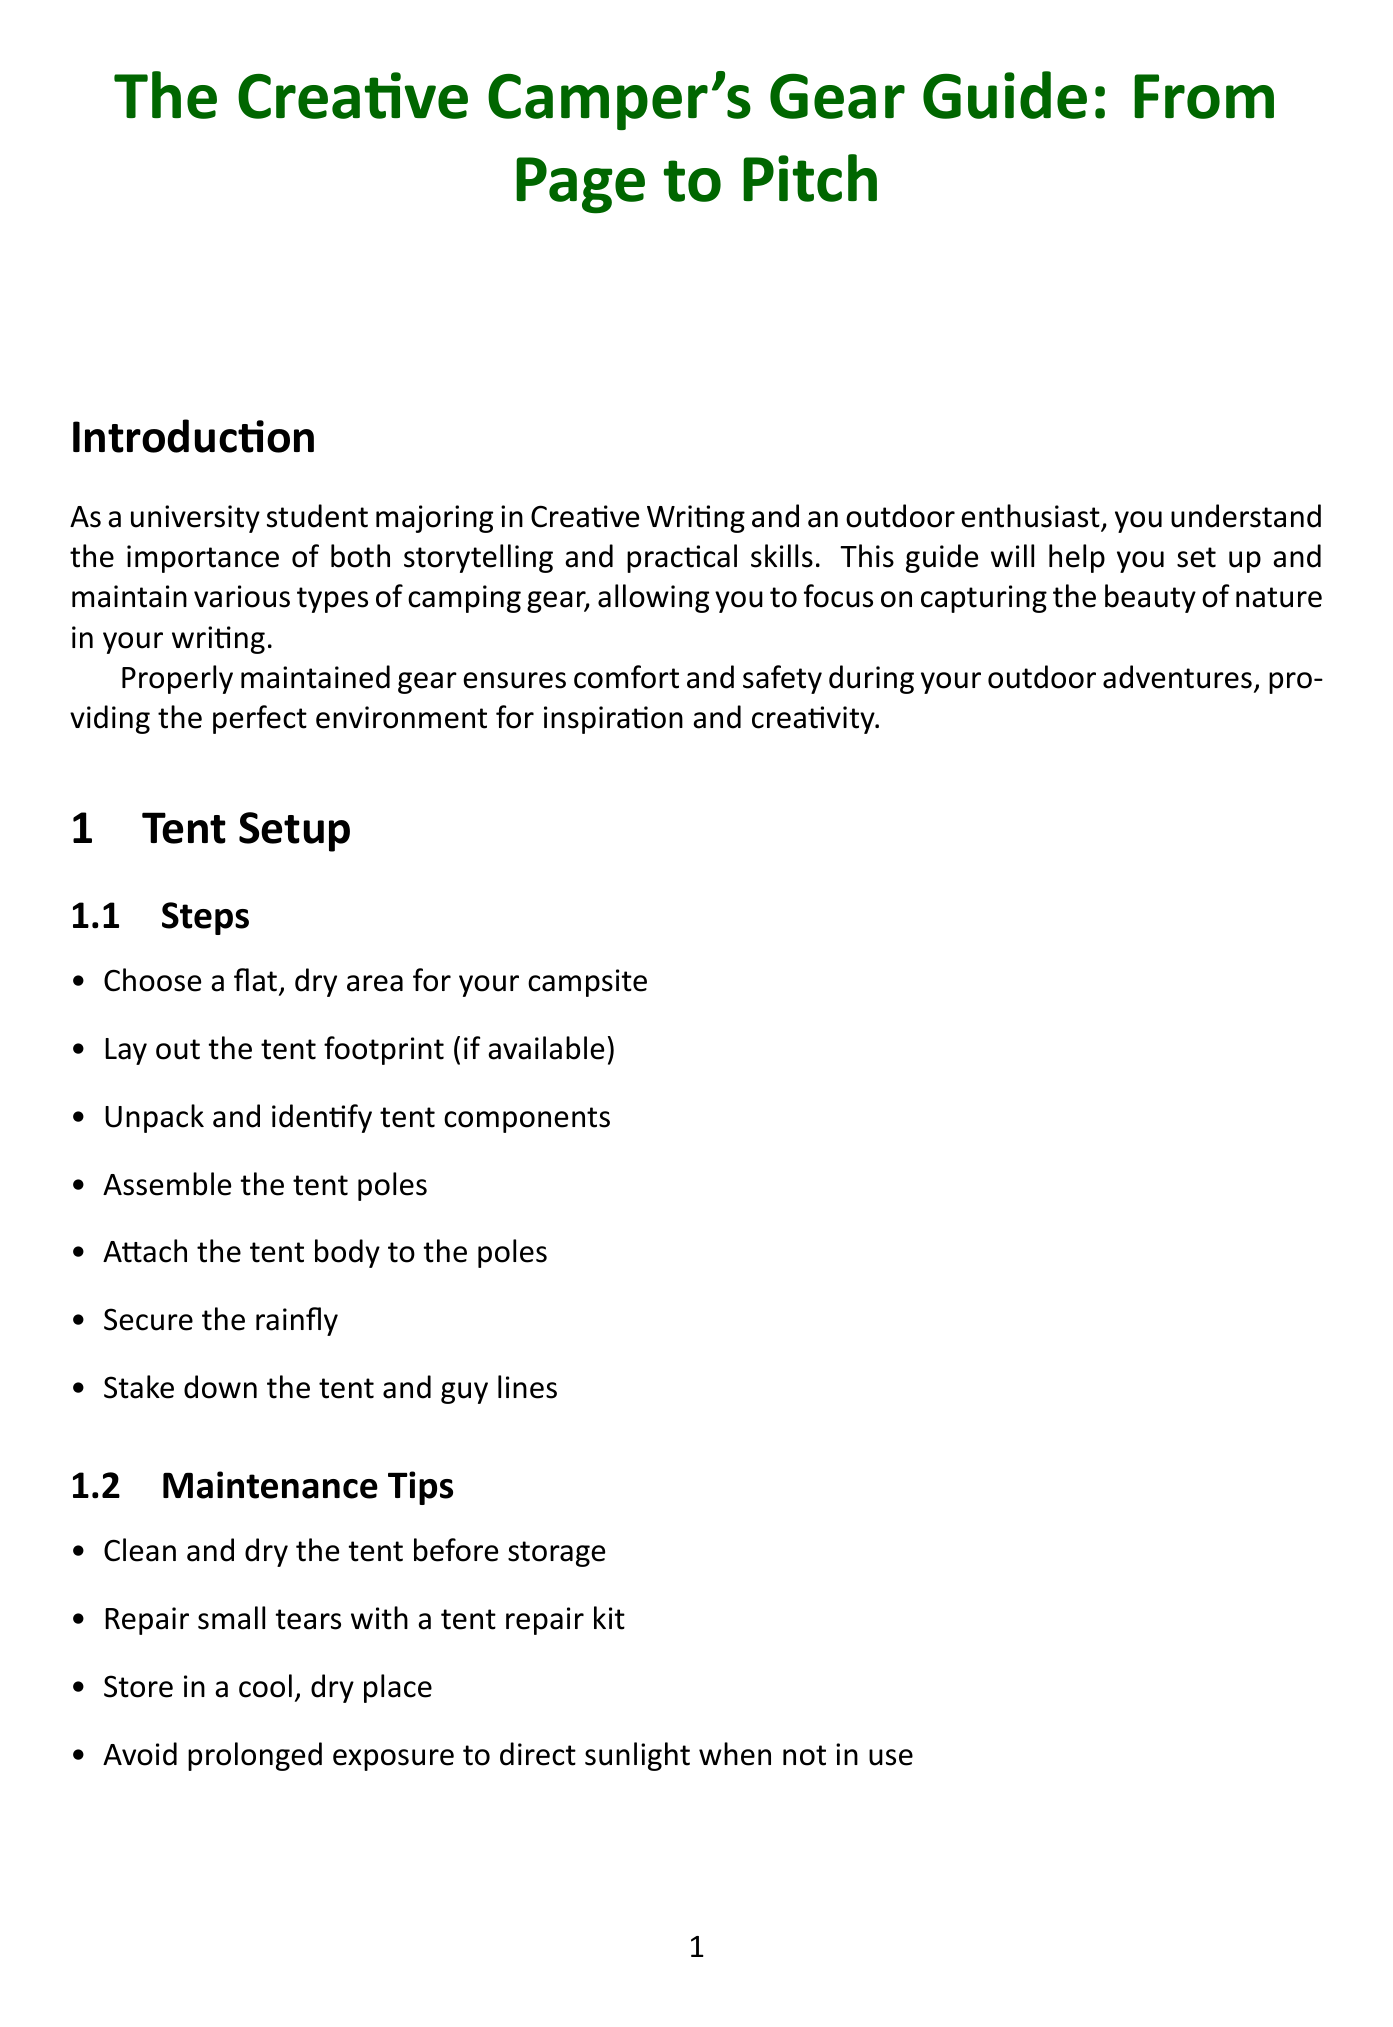What is the title of the guide? The title of the guide is stated prominently at the beginning of the document.
Answer: The Creative Camper's Gear Guide: From Page to Pitch How many steps are there for tent setup? The number of steps for tent setup is listed in the "Tent Setup" section.
Answer: Seven What are recommended models for sleeping bags? The recommended models are identified in the "Sleeping Bag Care" section.
Answer: Kelty Cosmic 20 Degree Down Sleeping Bag, Marmot Trestles 30 Synthetic Sleeping Bag, Western Mountaineering UltraLite Sleeping Bag What should you do after each use of your sleeping bag? The action recommended after each use is mentioned in the "Maintenance" section for sleeping bags.
Answer: Air out What temperature rating should you choose for your sleeping bag? This choice is mentioned as a crucial step in the "Sleeping Bag Care" setup instructions.
Answer: Appropriate temperature rating Which portable stove is recommended in the guide? The recommended models for portable stoves are listed in the "Portable Stove Operation" section.
Answer: MSR PocketRocket 2 Stove, Jetboil Flash Cooking System, Coleman Classic Propane Stove What is the first step in setting up a water filtration system? The first step is clearly outlined in the "Water Filtration Systems" setup instructions.
Answer: Identify a water source What should you do if you find small tears in your tent? The specific action for this issue is described in the "Maintenance Tips" for tents.
Answer: Repair with a repair kit How should you distribute weight in your backpack? The method for distribution is mentioned in the "Packing Tips" section.
Answer: Evenly 